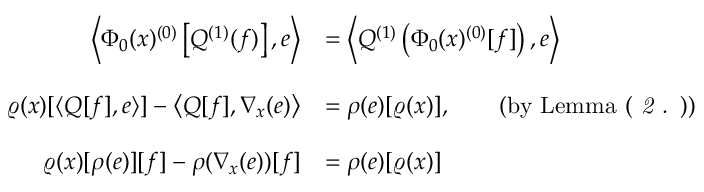Convert formula to latex. <formula><loc_0><loc_0><loc_500><loc_500>\begin{array} { r l } { \left \langle \Phi _ { 0 } ( x ) ^ { ( 0 ) } \left [ Q ^ { ( 1 ) } ( f ) \right ] , e \right \rangle } & { = \left \langle Q ^ { ( 1 ) } \left ( \Phi _ { 0 } ( x ) ^ { ( 0 ) } [ f ] \right ) , e \right \rangle } \\ \\ { \varrho ( x ) [ \langle Q [ f ] , e \rangle ] - \left \langle Q [ f ] , \nabla _ { x } ( e ) \right \rangle } & { = \rho ( e ) [ \varrho ( x ) ] , \quad ( b y L e m m a ( \emph { 2 . } ) ) } \\ \\ { \varrho ( x ) [ \rho ( e ) ] [ f ] - \rho ( \nabla _ { x } ( e ) ) [ f ] } & { = \rho ( e ) [ \varrho ( x ) ] } \end{array}</formula> 